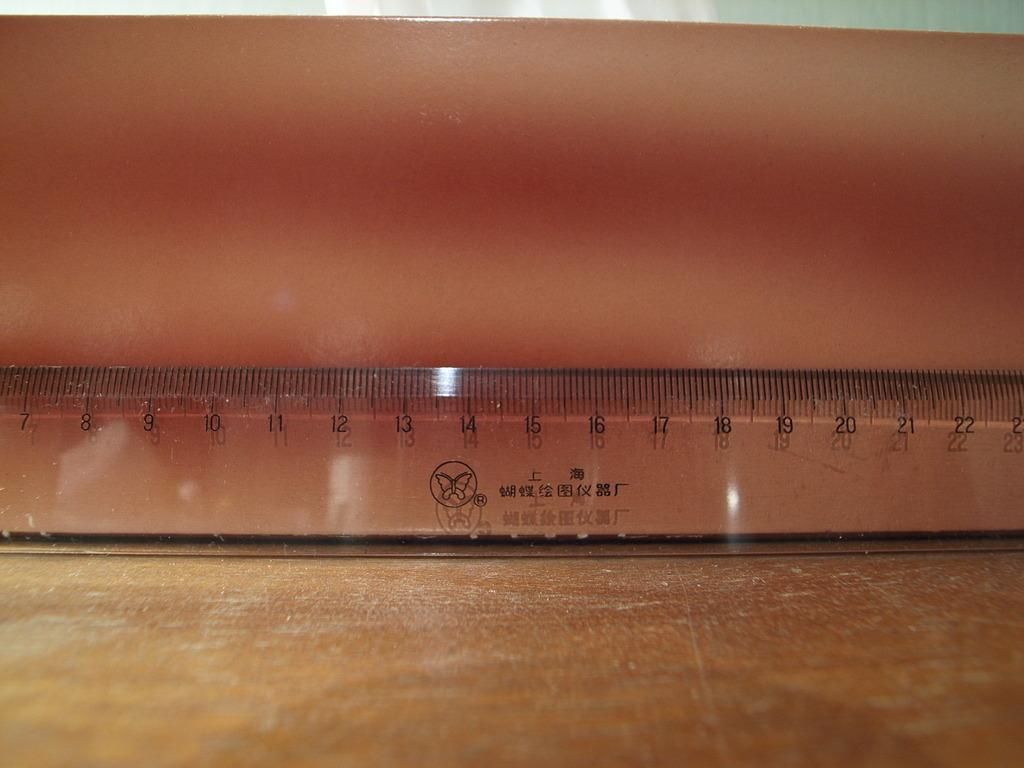<image>
Relay a brief, clear account of the picture shown. A clear ruler sits on a brown desk with numbers 7 through 22 visible. 